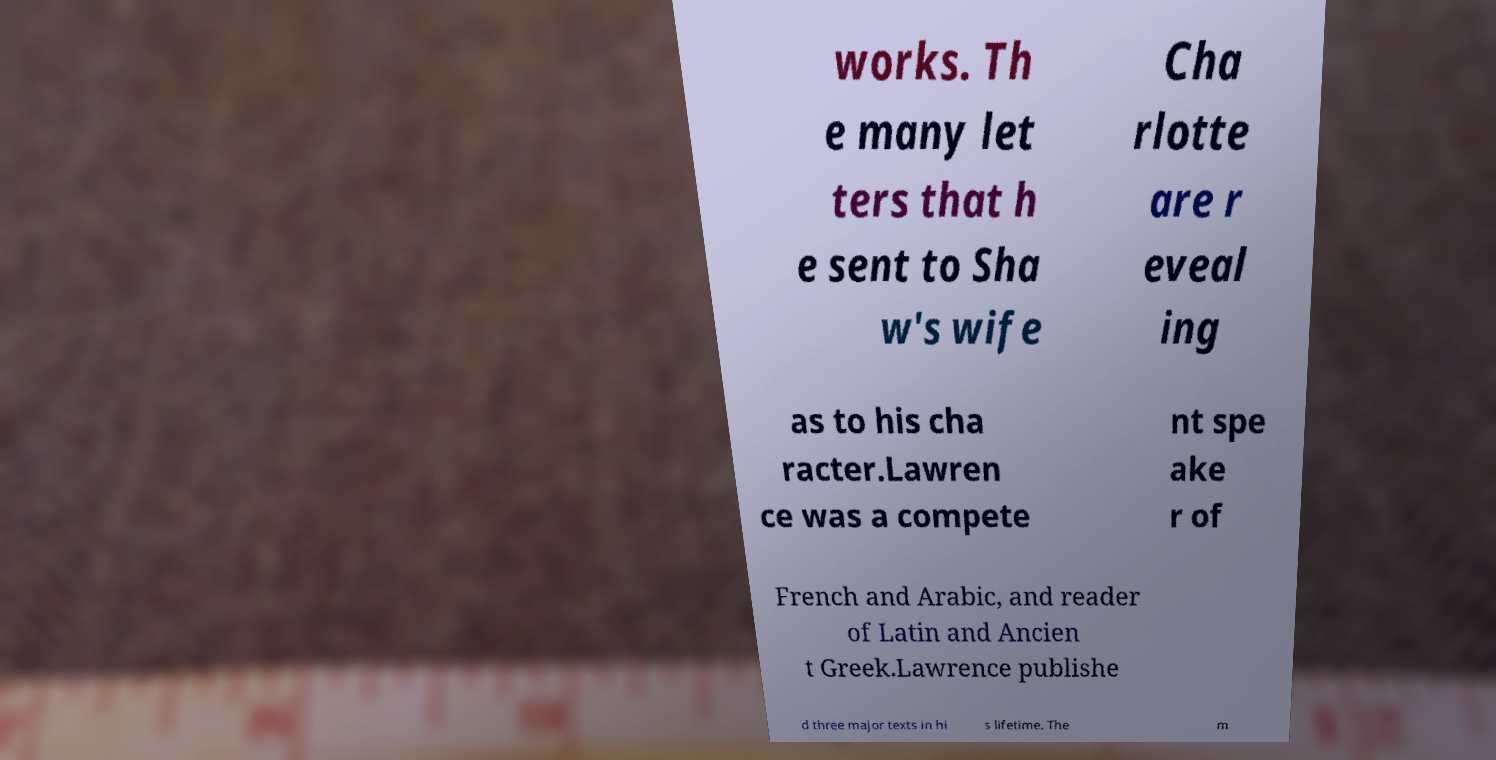Can you read and provide the text displayed in the image?This photo seems to have some interesting text. Can you extract and type it out for me? works. Th e many let ters that h e sent to Sha w's wife Cha rlotte are r eveal ing as to his cha racter.Lawren ce was a compete nt spe ake r of French and Arabic, and reader of Latin and Ancien t Greek.Lawrence publishe d three major texts in hi s lifetime. The m 